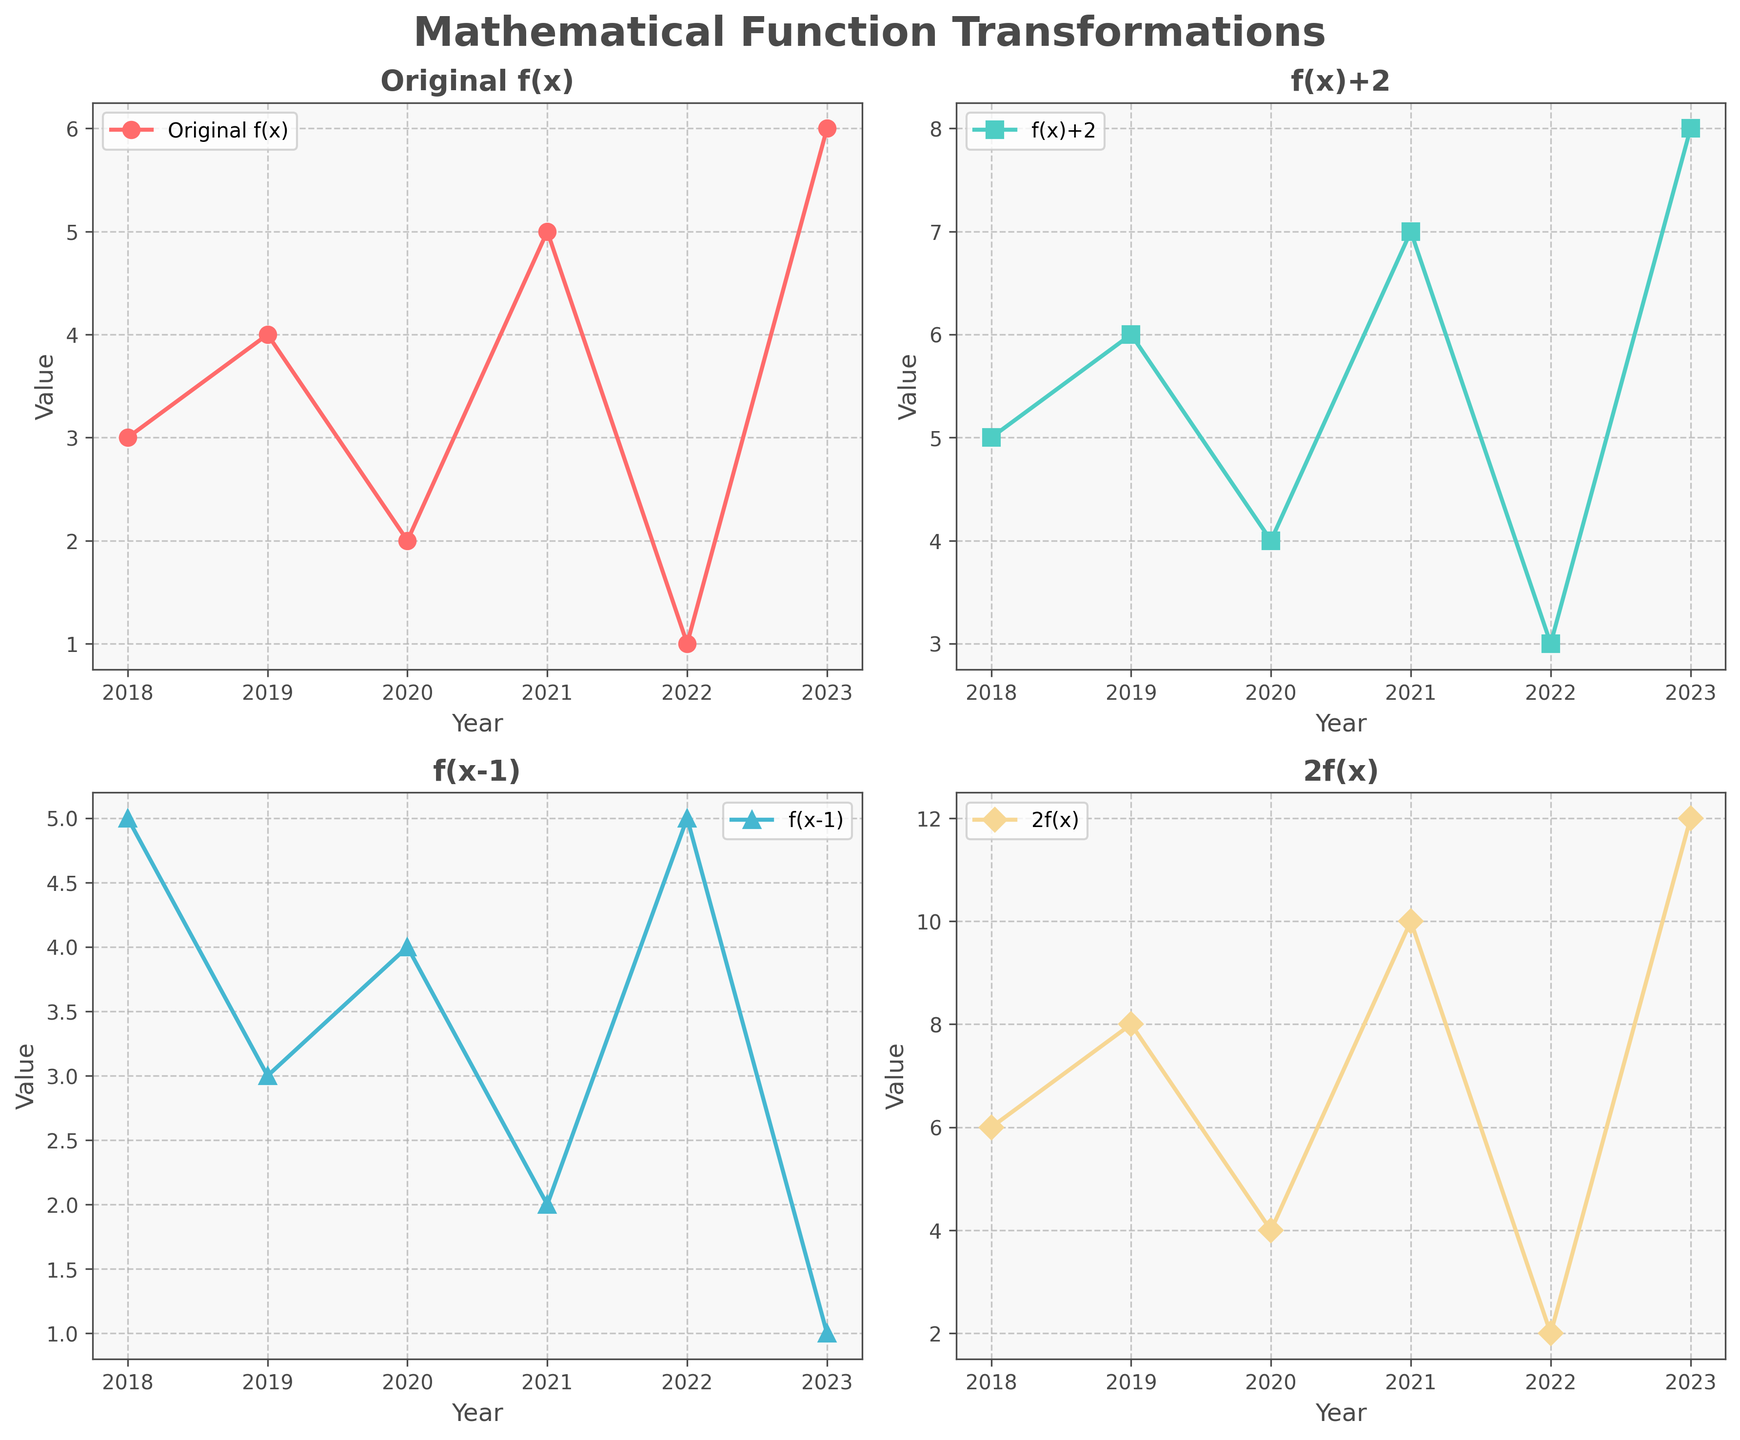What's the title of the figure? The title is at the top center of the figure in large, bold text and clearly states the purpose of the visualizations.
Answer: Mathematical Function Transformations How many subplots are there in the figure? The figure is divided into smaller plots, each displaying different function transformations. Count the individual sections.
Answer: 4 Which curve shows the transformation y=f(x)+2? Each subplot is labeled with the corresponding transformation in its title. Identify the subplot with the title "f(x)+2".
Answer: Top Right What is the value of y=kf(x) in 2020? Locate the subplot for the transformation y=kf(x), find the point for the year 2020, and read the corresponding value from the y-axis.
Answer: 4 Which transformation has the highest value in 2023? Compare the values in 2023 across all four subplots; identify which line reaches the highest point.
Answer: 2f(x) What is the difference between the values of y=f(x) and y=f(x-1) in 2019? Locate the points for the year 2019 on both subplots, read their values, and subtract to find the difference. f(x): 4, f(x-1): 3. Difference: 4 - 3.
Answer: 1 Are there any years where y=f(x-1) has a higher value than y=f(x)? Check each year’s values for both transformations, compare them, and find any instances where y=f(x-1) > y=f(x).
Answer: 2018 and 2022 How does the value of y=f(x)+2 change from 2020 to 2021? Observe the points for 2020 and 2021 on the y=f(x)+2 subplot, note the change by calculating the difference: 2021 value - 2020 value. 7 - 4.
Answer: Increases by 3 Which transformation experiences the largest increase from 2022 to 2023? Compare the changes in values from 2022 to 2023 for all four transformations and identify the largest increase. (2f(x): 10 increase, others have smaller changes).
Answer: 2f(x) What's the average value of y=f(x) over the years shown? Sum all the values of y=f(x) across the years (3+4+2+5+1+6), then divide by the number of years (6).
Answer: 3.5 